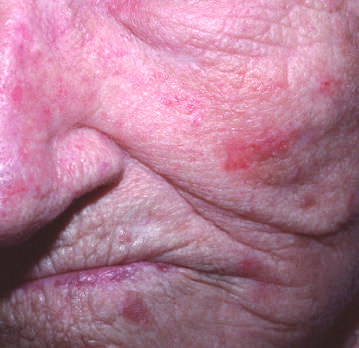re renal tubular epithelial cells in the lower half of the photograph present on the cheek and nose?
Answer the question using a single word or phrase. No 